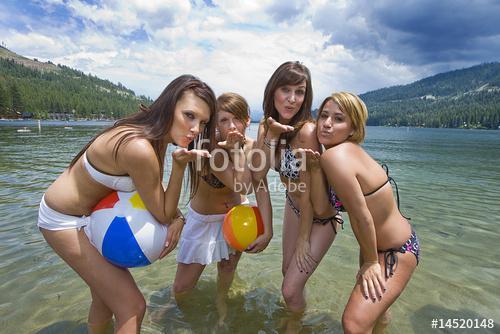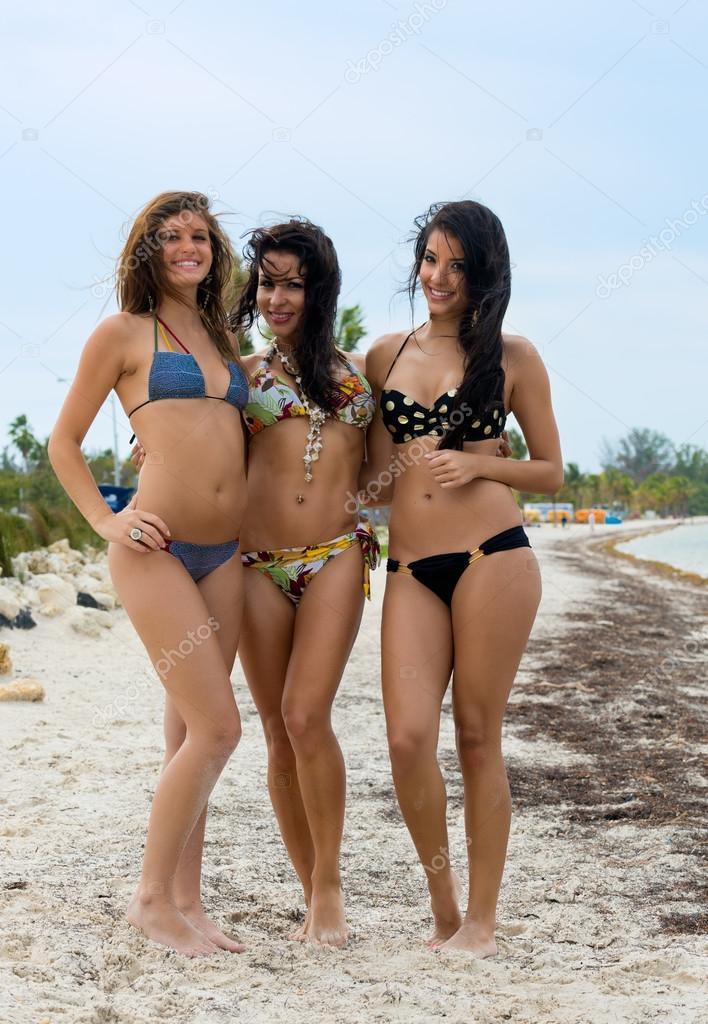The first image is the image on the left, the second image is the image on the right. Considering the images on both sides, is "An image shows three bikini models, with the one on the far right wearing a polka-dotted black top." valid? Answer yes or no. Yes. 